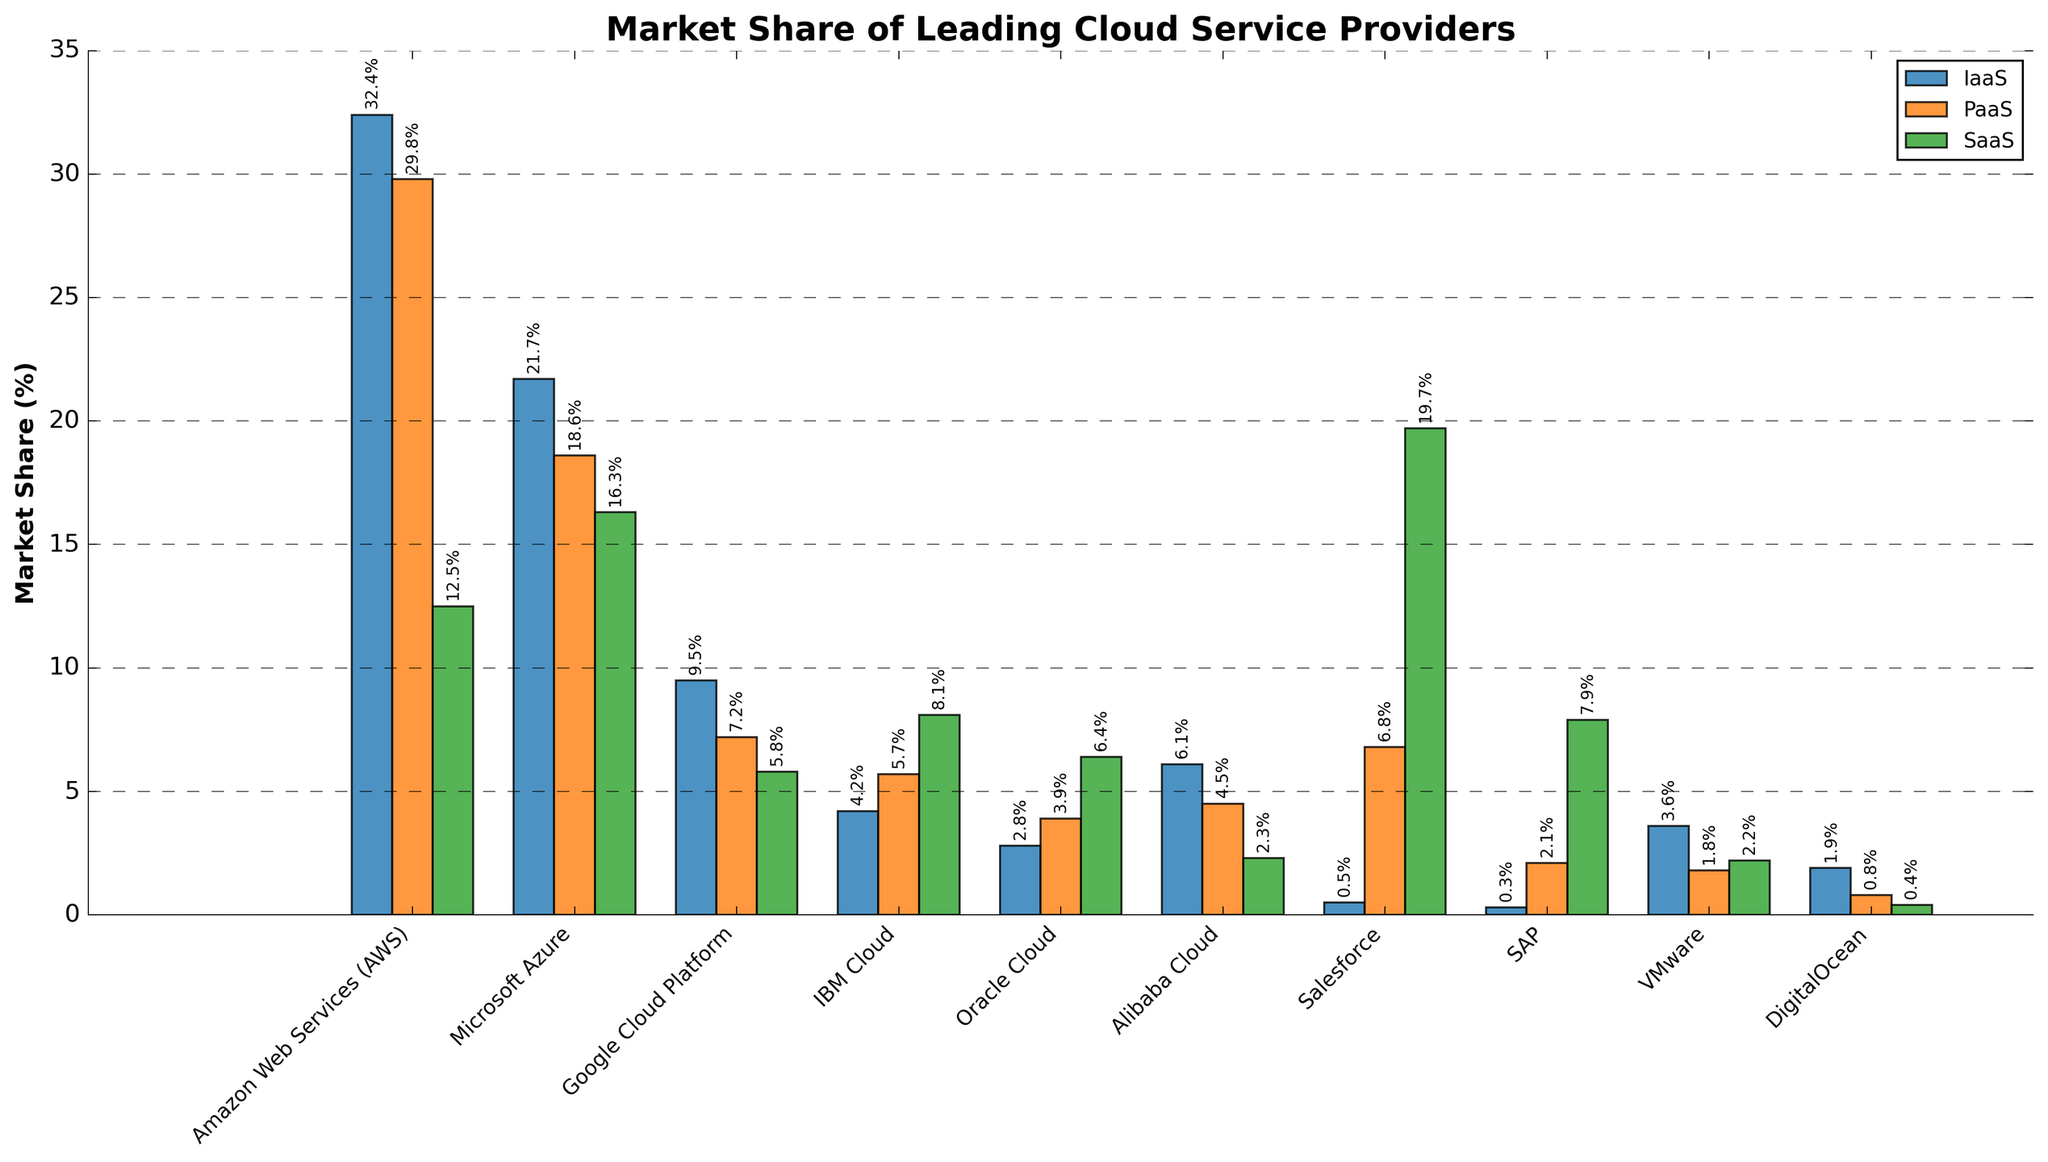what is the difference in market share between AWS and Microsoft Azure for IaaS? AWS has a market share of 32.4% in IaaS, while Microsoft Azure has 21.7%. Subtracting these values gives 32.4% - 21.7% = 10.7%.
Answer: 10.7% which cloud provider has the highest market share in SaaS? The bar labeled "Salesforce" stands out as the tallest in the SaaS category, representing the highest market share in this service type.
Answer: Salesforce what is the total market share of Alibaba Cloud across all service types? Summing the market shares of Alibaba Cloud in IaaS (6.1%), PaaS (4.5%), and SaaS (2.3%), gives 6.1% + 4.5% + 2.3% = 12.9%.
Answer: 12.9% compare the market share of Google Cloud Platform (GCP) and IBM Cloud in PaaS. Which is higher and by how much? GCP has 7.2% market share in PaaS, while IBM Cloud has 5.7%. Subtracting these values gives 7.2% - 5.7% = 1.5%, indicating that GCP has a 1.5% higher market share in PaaS than IBM Cloud.
Answer: GCP by 1.5% what is the total market share of VMware and SAP in SaaS? Adding the market shares of VMware (2.2%) and SAP (7.9%) in SaaS, gives 2.2% + 7.9% = 10.1%.
Answer: 10.1% which cloud provider has the smallest market share in PaaS? The bar representing DigitalOcean in the PaaS segment is the shortest, indicating the smallest market share.
Answer: DigitalOcean among AWS, Microsoft Azure, and Google Cloud Platform, which provider has the largest difference between its lowest and highest market share across all service types? AWS: IaaS (32.4%) - SaaS (12.5%) = 19.9%; Microsoft Azure: SaaS (16.3%) - PaaS (18.6%) = 2.3%; Google Cloud Platform: IaaS (9.5%) - SaaS (5.8%) = 3.7%. AWS has the largest difference of 19.9%.
Answer: AWS how do the market shares of Oracle Cloud and IBM Cloud in SaaS compare to each other? IBM Cloud has an 8.1% market share in SaaS, while Oracle Cloud has a 6.4% market share. IBM Cloud has a higher market share by 8.1% - 6.4% = 1.7%.
Answer: IBM Cloud by 1.7% if you combine the market shares of AWS and Alibaba Cloud in IaaS, what percentage of the market do they cover together? Summing the IaaS market shares of AWS (32.4%) and Alibaba Cloud (6.1%) gives 32.4% + 6.1% = 38.5%.
Answer: 38.5% what is the average market share of all providers in SaaS? Summing the SaaS market shares: 12.5% + 16.3% + 5.8% + 8.1% + 6.4% + 2.3% + 19.7% + 7.9% + 2.2% + 0.4% = 81.6%. There are 10 providers, so the average is 81.6% / 10 = 8.16%.
Answer: 8.16% 